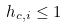<formula> <loc_0><loc_0><loc_500><loc_500>h _ { c , i } \leq 1</formula> 